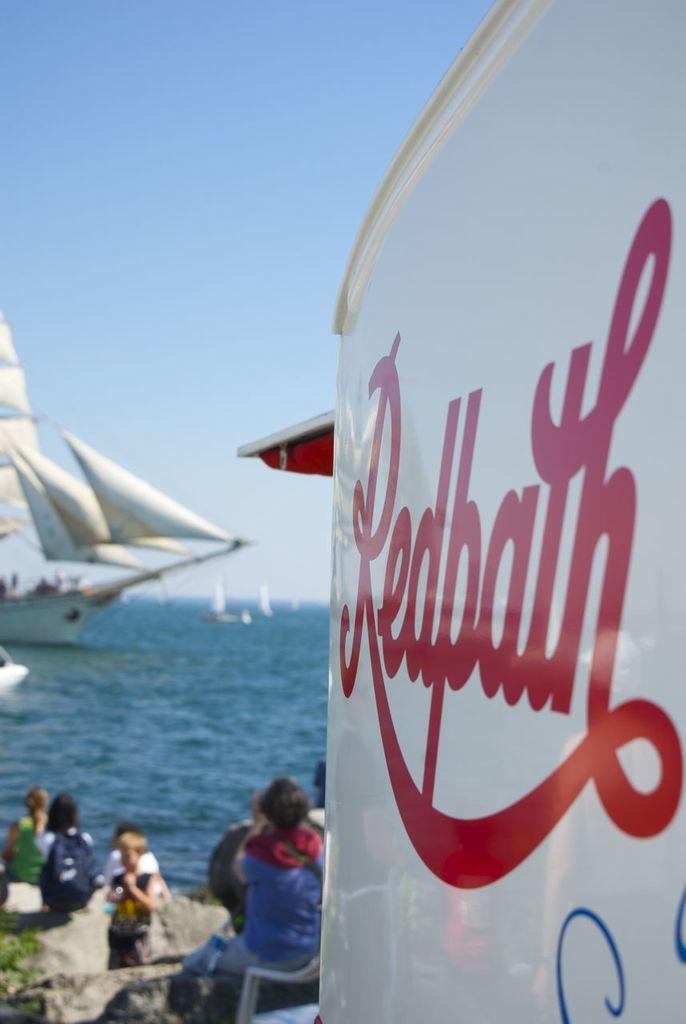What does the red text say?
Ensure brevity in your answer.  Redbath. 